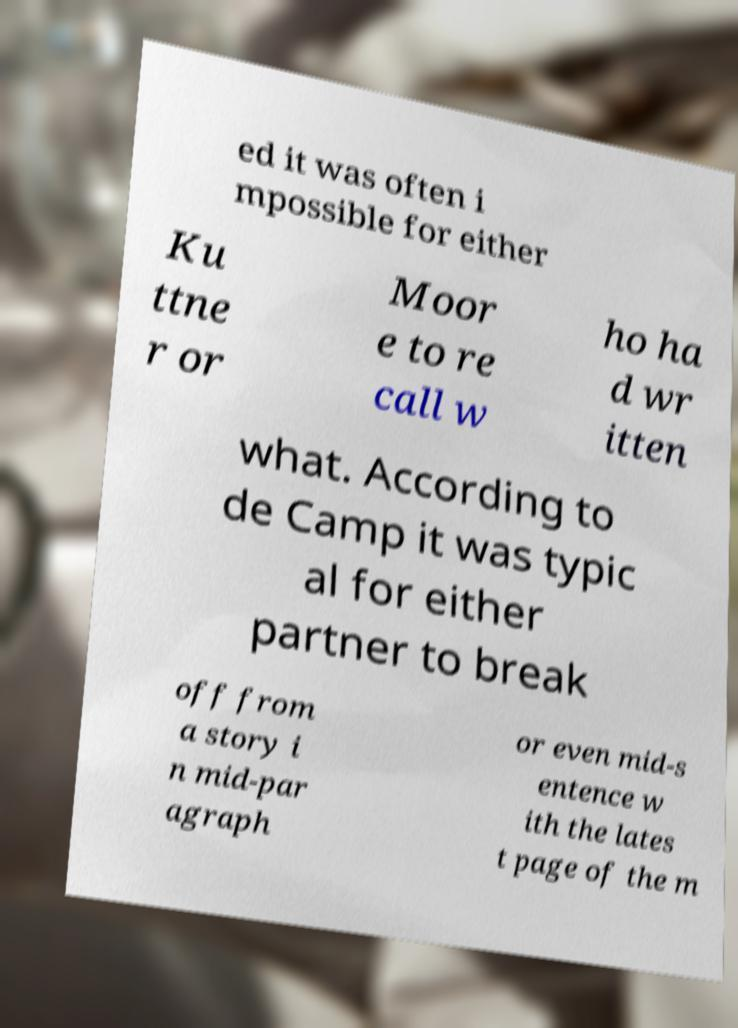Could you assist in decoding the text presented in this image and type it out clearly? ed it was often i mpossible for either Ku ttne r or Moor e to re call w ho ha d wr itten what. According to de Camp it was typic al for either partner to break off from a story i n mid-par agraph or even mid-s entence w ith the lates t page of the m 